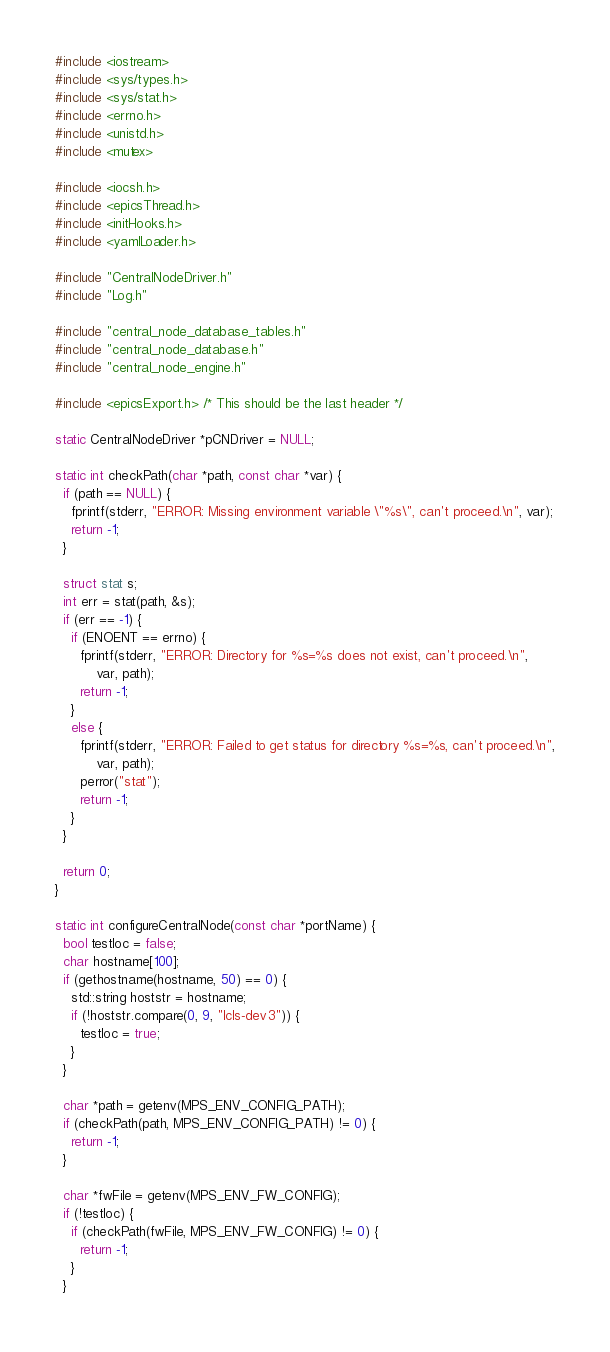<code> <loc_0><loc_0><loc_500><loc_500><_C++_>#include <iostream>
#include <sys/types.h>
#include <sys/stat.h>
#include <errno.h>
#include <unistd.h>
#include <mutex>

#include <iocsh.h>
#include <epicsThread.h>
#include <initHooks.h>
#include <yamlLoader.h>

#include "CentralNodeDriver.h"
#include "Log.h"

#include "central_node_database_tables.h"
#include "central_node_database.h"
#include "central_node_engine.h"

#include <epicsExport.h> /* This should be the last header */

static CentralNodeDriver *pCNDriver = NULL;

static int checkPath(char *path, const char *var) {
  if (path == NULL) {
    fprintf(stderr, "ERROR: Missing environment variable \"%s\", can't proceed.\n", var);
    return -1;
  }

  struct stat s;
  int err = stat(path, &s);
  if (err == -1) {
    if (ENOENT == errno) {
      fprintf(stderr, "ERROR: Directory for %s=%s does not exist, can't proceed.\n",
	      var, path);
      return -1;
    }
    else {
      fprintf(stderr, "ERROR: Failed to get status for directory %s=%s, can't proceed.\n",
	      var, path);
      perror("stat");
      return -1;
    }
  }

  return 0;
}

static int configureCentralNode(const char *portName) {
  bool testIoc = false;
  char hostname[100];
  if (gethostname(hostname, 50) == 0) {
    std::string hoststr = hostname;
    if (!hoststr.compare(0, 9, "lcls-dev3")) {
      testIoc = true;
    }
  }

  char *path = getenv(MPS_ENV_CONFIG_PATH);
  if (checkPath(path, MPS_ENV_CONFIG_PATH) != 0) {
    return -1;
  }

  char *fwFile = getenv(MPS_ENV_FW_CONFIG);
  if (!testIoc) {
    if (checkPath(fwFile, MPS_ENV_FW_CONFIG) != 0) {
      return -1;
    }
  }
</code> 